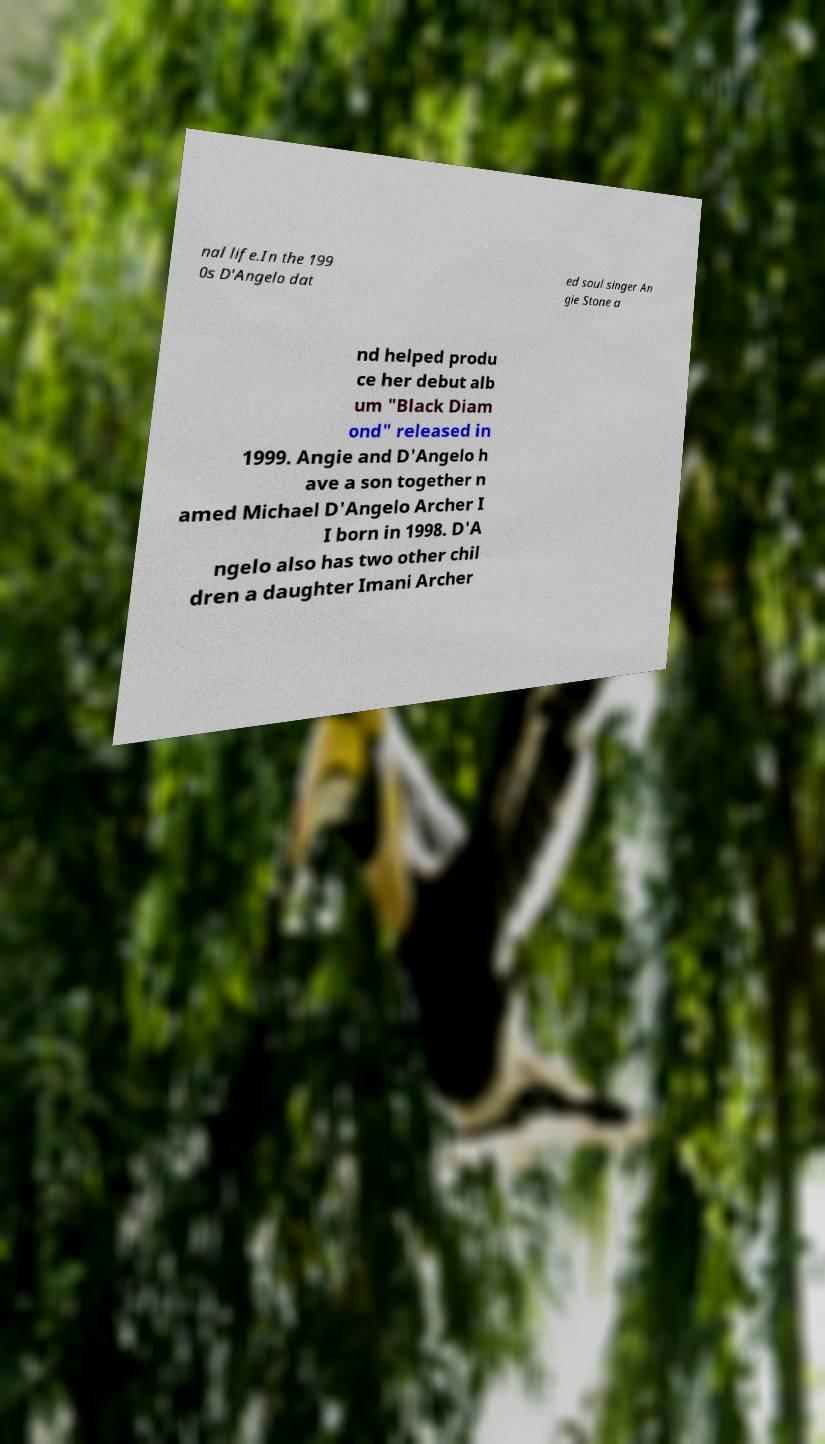Could you extract and type out the text from this image? nal life.In the 199 0s D'Angelo dat ed soul singer An gie Stone a nd helped produ ce her debut alb um "Black Diam ond" released in 1999. Angie and D'Angelo h ave a son together n amed Michael D'Angelo Archer I I born in 1998. D'A ngelo also has two other chil dren a daughter Imani Archer 